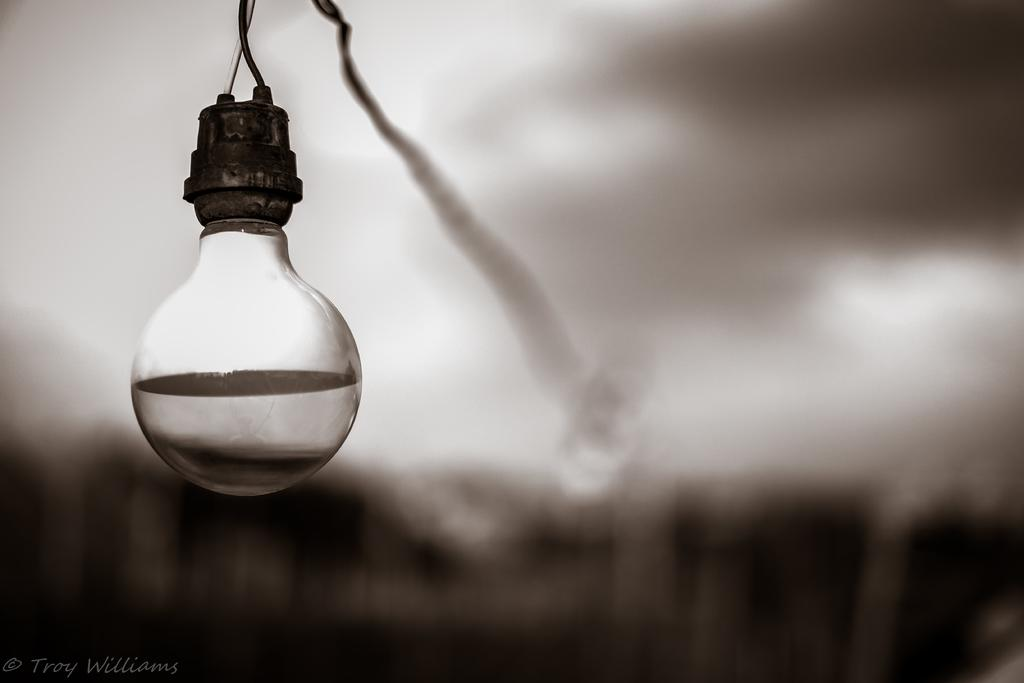What is the main object in the image? There is a light in the image. What is the light attached to? There is a holder in the image, which the light is attached to. Is there any visible connection between the light and the holder? Yes, there is a wire in the image that connects the light to the holder. How would you describe the overall appearance of the image? The background of the image is blurry. How many groups of jelly can be seen in the image? There is no jelly present in the image. 